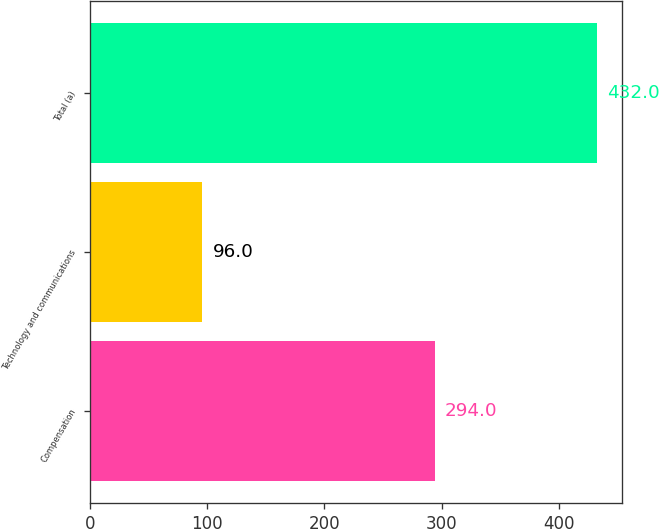Convert chart. <chart><loc_0><loc_0><loc_500><loc_500><bar_chart><fcel>Compensation<fcel>Technology and communications<fcel>Total (a)<nl><fcel>294<fcel>96<fcel>432<nl></chart> 